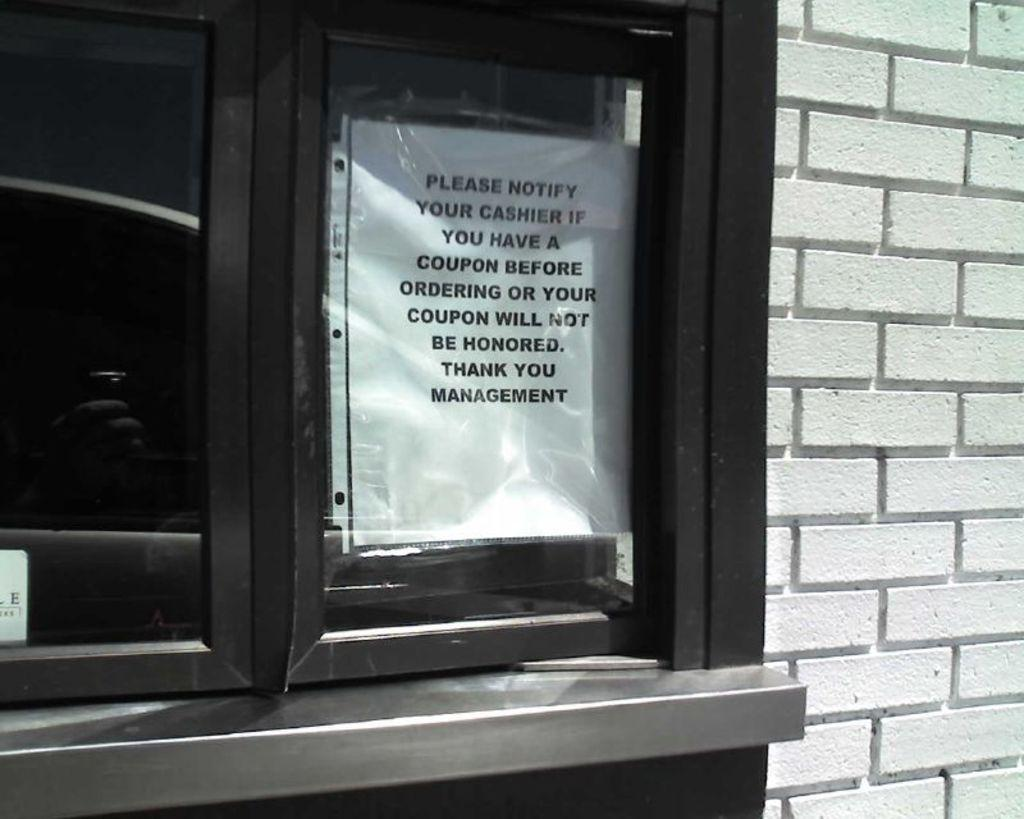Provide a one-sentence caption for the provided image. A drive thru window that has a sign up to notify cashier if you have a coupon or your coupon will not be honored written by management. 